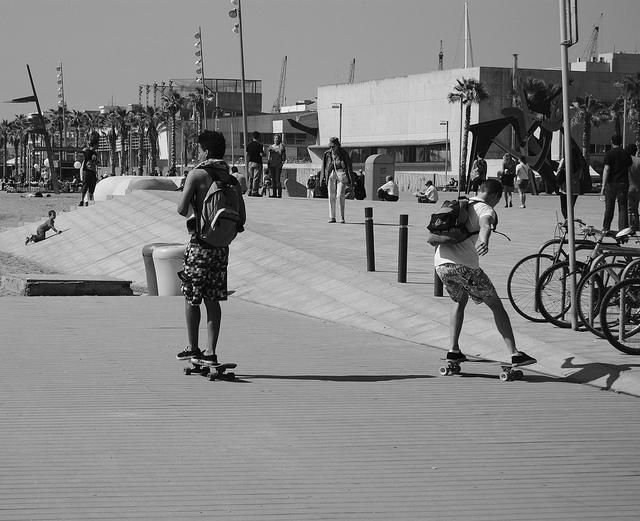How many children are in this photo?
Answer briefly. 2. Are they on Venice Beach?
Short answer required. Yes. How many bicycles are there?
Be succinct. 4. Who is riding the bike?
Short answer required. No one. Are either wearing jeans?
Short answer required. No. How many bikes are there?
Give a very brief answer. 4. Are there more skateboarders or bikers?
Give a very brief answer. Skateboarders. Is this a competition?
Answer briefly. No. Why is the person to the far left on their knees?
Write a very short answer. Crawling. 